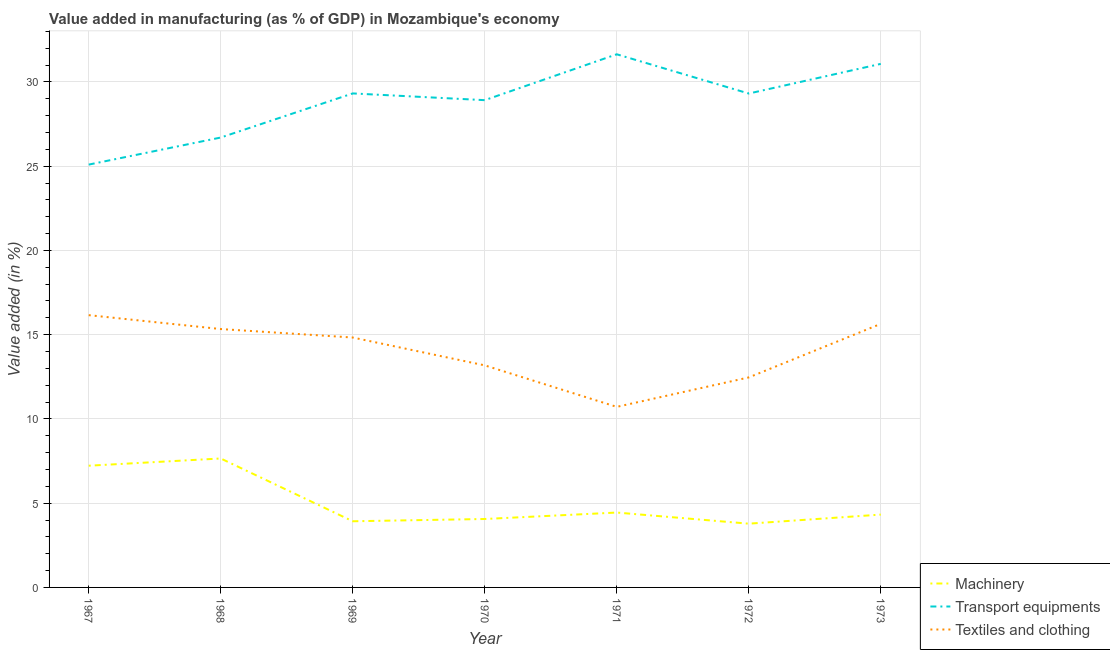How many different coloured lines are there?
Offer a terse response. 3. Does the line corresponding to value added in manufacturing machinery intersect with the line corresponding to value added in manufacturing transport equipments?
Keep it short and to the point. No. What is the value added in manufacturing textile and clothing in 1973?
Give a very brief answer. 15.64. Across all years, what is the maximum value added in manufacturing textile and clothing?
Your answer should be very brief. 16.16. Across all years, what is the minimum value added in manufacturing textile and clothing?
Ensure brevity in your answer.  10.72. In which year was the value added in manufacturing machinery maximum?
Provide a succinct answer. 1968. What is the total value added in manufacturing machinery in the graph?
Provide a short and direct response. 35.42. What is the difference between the value added in manufacturing machinery in 1968 and that in 1971?
Keep it short and to the point. 3.21. What is the difference between the value added in manufacturing transport equipments in 1967 and the value added in manufacturing machinery in 1970?
Ensure brevity in your answer.  21.03. What is the average value added in manufacturing machinery per year?
Your response must be concise. 5.06. In the year 1971, what is the difference between the value added in manufacturing machinery and value added in manufacturing textile and clothing?
Provide a short and direct response. -6.27. In how many years, is the value added in manufacturing transport equipments greater than 30 %?
Ensure brevity in your answer.  2. What is the ratio of the value added in manufacturing textile and clothing in 1967 to that in 1968?
Provide a short and direct response. 1.05. Is the value added in manufacturing textile and clothing in 1967 less than that in 1968?
Offer a very short reply. No. Is the difference between the value added in manufacturing machinery in 1967 and 1971 greater than the difference between the value added in manufacturing textile and clothing in 1967 and 1971?
Provide a succinct answer. No. What is the difference between the highest and the second highest value added in manufacturing machinery?
Your answer should be very brief. 0.43. What is the difference between the highest and the lowest value added in manufacturing transport equipments?
Offer a terse response. 6.55. In how many years, is the value added in manufacturing transport equipments greater than the average value added in manufacturing transport equipments taken over all years?
Your answer should be compact. 5. Is the sum of the value added in manufacturing textile and clothing in 1971 and 1972 greater than the maximum value added in manufacturing transport equipments across all years?
Offer a very short reply. No. Is the value added in manufacturing transport equipments strictly less than the value added in manufacturing machinery over the years?
Offer a very short reply. No. How many lines are there?
Make the answer very short. 3. How many years are there in the graph?
Make the answer very short. 7. What is the difference between two consecutive major ticks on the Y-axis?
Provide a short and direct response. 5. Does the graph contain grids?
Ensure brevity in your answer.  Yes. Where does the legend appear in the graph?
Your answer should be compact. Bottom right. How are the legend labels stacked?
Make the answer very short. Vertical. What is the title of the graph?
Give a very brief answer. Value added in manufacturing (as % of GDP) in Mozambique's economy. What is the label or title of the Y-axis?
Your answer should be very brief. Value added (in %). What is the Value added (in %) in Machinery in 1967?
Keep it short and to the point. 7.22. What is the Value added (in %) in Transport equipments in 1967?
Provide a succinct answer. 25.09. What is the Value added (in %) in Textiles and clothing in 1967?
Keep it short and to the point. 16.16. What is the Value added (in %) in Machinery in 1968?
Your answer should be very brief. 7.65. What is the Value added (in %) in Transport equipments in 1968?
Offer a terse response. 26.7. What is the Value added (in %) in Textiles and clothing in 1968?
Give a very brief answer. 15.33. What is the Value added (in %) in Machinery in 1969?
Offer a very short reply. 3.93. What is the Value added (in %) in Transport equipments in 1969?
Provide a short and direct response. 29.32. What is the Value added (in %) in Textiles and clothing in 1969?
Make the answer very short. 14.83. What is the Value added (in %) of Machinery in 1970?
Provide a succinct answer. 4.06. What is the Value added (in %) of Transport equipments in 1970?
Offer a terse response. 28.92. What is the Value added (in %) of Textiles and clothing in 1970?
Offer a terse response. 13.18. What is the Value added (in %) in Machinery in 1971?
Provide a short and direct response. 4.44. What is the Value added (in %) in Transport equipments in 1971?
Offer a terse response. 31.64. What is the Value added (in %) in Textiles and clothing in 1971?
Ensure brevity in your answer.  10.72. What is the Value added (in %) of Machinery in 1972?
Provide a succinct answer. 3.78. What is the Value added (in %) in Transport equipments in 1972?
Your answer should be very brief. 29.31. What is the Value added (in %) in Textiles and clothing in 1972?
Make the answer very short. 12.46. What is the Value added (in %) in Machinery in 1973?
Provide a short and direct response. 4.32. What is the Value added (in %) of Transport equipments in 1973?
Keep it short and to the point. 31.07. What is the Value added (in %) in Textiles and clothing in 1973?
Offer a very short reply. 15.64. Across all years, what is the maximum Value added (in %) of Machinery?
Provide a succinct answer. 7.65. Across all years, what is the maximum Value added (in %) of Transport equipments?
Your answer should be very brief. 31.64. Across all years, what is the maximum Value added (in %) in Textiles and clothing?
Offer a very short reply. 16.16. Across all years, what is the minimum Value added (in %) of Machinery?
Offer a terse response. 3.78. Across all years, what is the minimum Value added (in %) of Transport equipments?
Make the answer very short. 25.09. Across all years, what is the minimum Value added (in %) in Textiles and clothing?
Provide a short and direct response. 10.72. What is the total Value added (in %) of Machinery in the graph?
Provide a short and direct response. 35.42. What is the total Value added (in %) of Transport equipments in the graph?
Make the answer very short. 202.06. What is the total Value added (in %) in Textiles and clothing in the graph?
Your response must be concise. 98.33. What is the difference between the Value added (in %) in Machinery in 1967 and that in 1968?
Your answer should be very brief. -0.43. What is the difference between the Value added (in %) of Transport equipments in 1967 and that in 1968?
Your answer should be compact. -1.61. What is the difference between the Value added (in %) in Textiles and clothing in 1967 and that in 1968?
Offer a very short reply. 0.82. What is the difference between the Value added (in %) of Machinery in 1967 and that in 1969?
Your answer should be very brief. 3.3. What is the difference between the Value added (in %) in Transport equipments in 1967 and that in 1969?
Offer a very short reply. -4.22. What is the difference between the Value added (in %) in Textiles and clothing in 1967 and that in 1969?
Your answer should be very brief. 1.33. What is the difference between the Value added (in %) in Machinery in 1967 and that in 1970?
Offer a very short reply. 3.16. What is the difference between the Value added (in %) of Transport equipments in 1967 and that in 1970?
Ensure brevity in your answer.  -3.82. What is the difference between the Value added (in %) in Textiles and clothing in 1967 and that in 1970?
Offer a terse response. 2.98. What is the difference between the Value added (in %) of Machinery in 1967 and that in 1971?
Make the answer very short. 2.78. What is the difference between the Value added (in %) of Transport equipments in 1967 and that in 1971?
Offer a very short reply. -6.55. What is the difference between the Value added (in %) of Textiles and clothing in 1967 and that in 1971?
Your answer should be compact. 5.44. What is the difference between the Value added (in %) of Machinery in 1967 and that in 1972?
Give a very brief answer. 3.44. What is the difference between the Value added (in %) in Transport equipments in 1967 and that in 1972?
Provide a succinct answer. -4.22. What is the difference between the Value added (in %) of Textiles and clothing in 1967 and that in 1972?
Your answer should be very brief. 3.69. What is the difference between the Value added (in %) of Machinery in 1967 and that in 1973?
Provide a short and direct response. 2.9. What is the difference between the Value added (in %) in Transport equipments in 1967 and that in 1973?
Provide a short and direct response. -5.98. What is the difference between the Value added (in %) of Textiles and clothing in 1967 and that in 1973?
Provide a short and direct response. 0.52. What is the difference between the Value added (in %) of Machinery in 1968 and that in 1969?
Provide a short and direct response. 3.73. What is the difference between the Value added (in %) of Transport equipments in 1968 and that in 1969?
Your response must be concise. -2.62. What is the difference between the Value added (in %) in Textiles and clothing in 1968 and that in 1969?
Provide a short and direct response. 0.5. What is the difference between the Value added (in %) in Machinery in 1968 and that in 1970?
Make the answer very short. 3.59. What is the difference between the Value added (in %) in Transport equipments in 1968 and that in 1970?
Give a very brief answer. -2.22. What is the difference between the Value added (in %) in Textiles and clothing in 1968 and that in 1970?
Your response must be concise. 2.16. What is the difference between the Value added (in %) in Machinery in 1968 and that in 1971?
Provide a short and direct response. 3.21. What is the difference between the Value added (in %) of Transport equipments in 1968 and that in 1971?
Your answer should be compact. -4.94. What is the difference between the Value added (in %) of Textiles and clothing in 1968 and that in 1971?
Your response must be concise. 4.62. What is the difference between the Value added (in %) of Machinery in 1968 and that in 1972?
Make the answer very short. 3.87. What is the difference between the Value added (in %) in Transport equipments in 1968 and that in 1972?
Provide a succinct answer. -2.61. What is the difference between the Value added (in %) in Textiles and clothing in 1968 and that in 1972?
Your response must be concise. 2.87. What is the difference between the Value added (in %) of Machinery in 1968 and that in 1973?
Your answer should be very brief. 3.33. What is the difference between the Value added (in %) in Transport equipments in 1968 and that in 1973?
Offer a very short reply. -4.37. What is the difference between the Value added (in %) of Textiles and clothing in 1968 and that in 1973?
Keep it short and to the point. -0.31. What is the difference between the Value added (in %) in Machinery in 1969 and that in 1970?
Provide a short and direct response. -0.14. What is the difference between the Value added (in %) in Transport equipments in 1969 and that in 1970?
Ensure brevity in your answer.  0.4. What is the difference between the Value added (in %) in Textiles and clothing in 1969 and that in 1970?
Offer a very short reply. 1.65. What is the difference between the Value added (in %) in Machinery in 1969 and that in 1971?
Your answer should be very brief. -0.52. What is the difference between the Value added (in %) of Transport equipments in 1969 and that in 1971?
Give a very brief answer. -2.32. What is the difference between the Value added (in %) of Textiles and clothing in 1969 and that in 1971?
Your response must be concise. 4.12. What is the difference between the Value added (in %) in Machinery in 1969 and that in 1972?
Your response must be concise. 0.14. What is the difference between the Value added (in %) of Transport equipments in 1969 and that in 1972?
Your response must be concise. 0.01. What is the difference between the Value added (in %) of Textiles and clothing in 1969 and that in 1972?
Ensure brevity in your answer.  2.37. What is the difference between the Value added (in %) in Machinery in 1969 and that in 1973?
Make the answer very short. -0.4. What is the difference between the Value added (in %) of Transport equipments in 1969 and that in 1973?
Your answer should be very brief. -1.75. What is the difference between the Value added (in %) of Textiles and clothing in 1969 and that in 1973?
Provide a succinct answer. -0.81. What is the difference between the Value added (in %) in Machinery in 1970 and that in 1971?
Make the answer very short. -0.38. What is the difference between the Value added (in %) of Transport equipments in 1970 and that in 1971?
Provide a succinct answer. -2.72. What is the difference between the Value added (in %) in Textiles and clothing in 1970 and that in 1971?
Provide a succinct answer. 2.46. What is the difference between the Value added (in %) in Machinery in 1970 and that in 1972?
Provide a succinct answer. 0.28. What is the difference between the Value added (in %) of Transport equipments in 1970 and that in 1972?
Give a very brief answer. -0.39. What is the difference between the Value added (in %) of Textiles and clothing in 1970 and that in 1972?
Make the answer very short. 0.71. What is the difference between the Value added (in %) of Machinery in 1970 and that in 1973?
Keep it short and to the point. -0.26. What is the difference between the Value added (in %) of Transport equipments in 1970 and that in 1973?
Your answer should be very brief. -2.15. What is the difference between the Value added (in %) in Textiles and clothing in 1970 and that in 1973?
Provide a short and direct response. -2.46. What is the difference between the Value added (in %) of Machinery in 1971 and that in 1972?
Your answer should be compact. 0.66. What is the difference between the Value added (in %) in Transport equipments in 1971 and that in 1972?
Offer a very short reply. 2.33. What is the difference between the Value added (in %) of Textiles and clothing in 1971 and that in 1972?
Your answer should be compact. -1.75. What is the difference between the Value added (in %) in Machinery in 1971 and that in 1973?
Offer a very short reply. 0.12. What is the difference between the Value added (in %) in Transport equipments in 1971 and that in 1973?
Ensure brevity in your answer.  0.57. What is the difference between the Value added (in %) of Textiles and clothing in 1971 and that in 1973?
Provide a short and direct response. -4.93. What is the difference between the Value added (in %) in Machinery in 1972 and that in 1973?
Give a very brief answer. -0.54. What is the difference between the Value added (in %) in Transport equipments in 1972 and that in 1973?
Your response must be concise. -1.76. What is the difference between the Value added (in %) of Textiles and clothing in 1972 and that in 1973?
Make the answer very short. -3.18. What is the difference between the Value added (in %) of Machinery in 1967 and the Value added (in %) of Transport equipments in 1968?
Ensure brevity in your answer.  -19.48. What is the difference between the Value added (in %) in Machinery in 1967 and the Value added (in %) in Textiles and clothing in 1968?
Ensure brevity in your answer.  -8.11. What is the difference between the Value added (in %) of Transport equipments in 1967 and the Value added (in %) of Textiles and clothing in 1968?
Your response must be concise. 9.76. What is the difference between the Value added (in %) in Machinery in 1967 and the Value added (in %) in Transport equipments in 1969?
Ensure brevity in your answer.  -22.09. What is the difference between the Value added (in %) of Machinery in 1967 and the Value added (in %) of Textiles and clothing in 1969?
Your answer should be compact. -7.61. What is the difference between the Value added (in %) of Transport equipments in 1967 and the Value added (in %) of Textiles and clothing in 1969?
Your answer should be very brief. 10.26. What is the difference between the Value added (in %) of Machinery in 1967 and the Value added (in %) of Transport equipments in 1970?
Your answer should be very brief. -21.69. What is the difference between the Value added (in %) of Machinery in 1967 and the Value added (in %) of Textiles and clothing in 1970?
Make the answer very short. -5.96. What is the difference between the Value added (in %) of Transport equipments in 1967 and the Value added (in %) of Textiles and clothing in 1970?
Provide a succinct answer. 11.92. What is the difference between the Value added (in %) of Machinery in 1967 and the Value added (in %) of Transport equipments in 1971?
Your answer should be very brief. -24.42. What is the difference between the Value added (in %) in Machinery in 1967 and the Value added (in %) in Textiles and clothing in 1971?
Give a very brief answer. -3.49. What is the difference between the Value added (in %) in Transport equipments in 1967 and the Value added (in %) in Textiles and clothing in 1971?
Provide a short and direct response. 14.38. What is the difference between the Value added (in %) of Machinery in 1967 and the Value added (in %) of Transport equipments in 1972?
Give a very brief answer. -22.09. What is the difference between the Value added (in %) of Machinery in 1967 and the Value added (in %) of Textiles and clothing in 1972?
Offer a terse response. -5.24. What is the difference between the Value added (in %) in Transport equipments in 1967 and the Value added (in %) in Textiles and clothing in 1972?
Offer a very short reply. 12.63. What is the difference between the Value added (in %) of Machinery in 1967 and the Value added (in %) of Transport equipments in 1973?
Your answer should be compact. -23.85. What is the difference between the Value added (in %) in Machinery in 1967 and the Value added (in %) in Textiles and clothing in 1973?
Your response must be concise. -8.42. What is the difference between the Value added (in %) of Transport equipments in 1967 and the Value added (in %) of Textiles and clothing in 1973?
Ensure brevity in your answer.  9.45. What is the difference between the Value added (in %) in Machinery in 1968 and the Value added (in %) in Transport equipments in 1969?
Provide a short and direct response. -21.67. What is the difference between the Value added (in %) in Machinery in 1968 and the Value added (in %) in Textiles and clothing in 1969?
Your answer should be compact. -7.18. What is the difference between the Value added (in %) in Transport equipments in 1968 and the Value added (in %) in Textiles and clothing in 1969?
Your answer should be very brief. 11.87. What is the difference between the Value added (in %) of Machinery in 1968 and the Value added (in %) of Transport equipments in 1970?
Ensure brevity in your answer.  -21.27. What is the difference between the Value added (in %) in Machinery in 1968 and the Value added (in %) in Textiles and clothing in 1970?
Ensure brevity in your answer.  -5.53. What is the difference between the Value added (in %) in Transport equipments in 1968 and the Value added (in %) in Textiles and clothing in 1970?
Your answer should be very brief. 13.52. What is the difference between the Value added (in %) of Machinery in 1968 and the Value added (in %) of Transport equipments in 1971?
Your response must be concise. -23.99. What is the difference between the Value added (in %) in Machinery in 1968 and the Value added (in %) in Textiles and clothing in 1971?
Offer a very short reply. -3.06. What is the difference between the Value added (in %) in Transport equipments in 1968 and the Value added (in %) in Textiles and clothing in 1971?
Offer a terse response. 15.98. What is the difference between the Value added (in %) in Machinery in 1968 and the Value added (in %) in Transport equipments in 1972?
Make the answer very short. -21.66. What is the difference between the Value added (in %) in Machinery in 1968 and the Value added (in %) in Textiles and clothing in 1972?
Your answer should be very brief. -4.81. What is the difference between the Value added (in %) in Transport equipments in 1968 and the Value added (in %) in Textiles and clothing in 1972?
Your answer should be compact. 14.24. What is the difference between the Value added (in %) of Machinery in 1968 and the Value added (in %) of Transport equipments in 1973?
Keep it short and to the point. -23.42. What is the difference between the Value added (in %) of Machinery in 1968 and the Value added (in %) of Textiles and clothing in 1973?
Offer a very short reply. -7.99. What is the difference between the Value added (in %) in Transport equipments in 1968 and the Value added (in %) in Textiles and clothing in 1973?
Keep it short and to the point. 11.06. What is the difference between the Value added (in %) of Machinery in 1969 and the Value added (in %) of Transport equipments in 1970?
Make the answer very short. -24.99. What is the difference between the Value added (in %) in Machinery in 1969 and the Value added (in %) in Textiles and clothing in 1970?
Provide a short and direct response. -9.25. What is the difference between the Value added (in %) of Transport equipments in 1969 and the Value added (in %) of Textiles and clothing in 1970?
Keep it short and to the point. 16.14. What is the difference between the Value added (in %) in Machinery in 1969 and the Value added (in %) in Transport equipments in 1971?
Give a very brief answer. -27.71. What is the difference between the Value added (in %) in Machinery in 1969 and the Value added (in %) in Textiles and clothing in 1971?
Provide a short and direct response. -6.79. What is the difference between the Value added (in %) of Transport equipments in 1969 and the Value added (in %) of Textiles and clothing in 1971?
Your answer should be compact. 18.6. What is the difference between the Value added (in %) in Machinery in 1969 and the Value added (in %) in Transport equipments in 1972?
Your response must be concise. -25.39. What is the difference between the Value added (in %) of Machinery in 1969 and the Value added (in %) of Textiles and clothing in 1972?
Provide a short and direct response. -8.54. What is the difference between the Value added (in %) in Transport equipments in 1969 and the Value added (in %) in Textiles and clothing in 1972?
Provide a short and direct response. 16.85. What is the difference between the Value added (in %) in Machinery in 1969 and the Value added (in %) in Transport equipments in 1973?
Your answer should be compact. -27.15. What is the difference between the Value added (in %) of Machinery in 1969 and the Value added (in %) of Textiles and clothing in 1973?
Offer a terse response. -11.72. What is the difference between the Value added (in %) of Transport equipments in 1969 and the Value added (in %) of Textiles and clothing in 1973?
Provide a short and direct response. 13.68. What is the difference between the Value added (in %) in Machinery in 1970 and the Value added (in %) in Transport equipments in 1971?
Ensure brevity in your answer.  -27.58. What is the difference between the Value added (in %) of Machinery in 1970 and the Value added (in %) of Textiles and clothing in 1971?
Your response must be concise. -6.65. What is the difference between the Value added (in %) in Transport equipments in 1970 and the Value added (in %) in Textiles and clothing in 1971?
Keep it short and to the point. 18.2. What is the difference between the Value added (in %) in Machinery in 1970 and the Value added (in %) in Transport equipments in 1972?
Provide a short and direct response. -25.25. What is the difference between the Value added (in %) of Machinery in 1970 and the Value added (in %) of Textiles and clothing in 1972?
Give a very brief answer. -8.4. What is the difference between the Value added (in %) of Transport equipments in 1970 and the Value added (in %) of Textiles and clothing in 1972?
Make the answer very short. 16.45. What is the difference between the Value added (in %) in Machinery in 1970 and the Value added (in %) in Transport equipments in 1973?
Your answer should be very brief. -27.01. What is the difference between the Value added (in %) of Machinery in 1970 and the Value added (in %) of Textiles and clothing in 1973?
Provide a short and direct response. -11.58. What is the difference between the Value added (in %) in Transport equipments in 1970 and the Value added (in %) in Textiles and clothing in 1973?
Your answer should be very brief. 13.28. What is the difference between the Value added (in %) in Machinery in 1971 and the Value added (in %) in Transport equipments in 1972?
Keep it short and to the point. -24.87. What is the difference between the Value added (in %) of Machinery in 1971 and the Value added (in %) of Textiles and clothing in 1972?
Provide a short and direct response. -8.02. What is the difference between the Value added (in %) of Transport equipments in 1971 and the Value added (in %) of Textiles and clothing in 1972?
Your answer should be very brief. 19.18. What is the difference between the Value added (in %) in Machinery in 1971 and the Value added (in %) in Transport equipments in 1973?
Offer a very short reply. -26.63. What is the difference between the Value added (in %) of Machinery in 1971 and the Value added (in %) of Textiles and clothing in 1973?
Give a very brief answer. -11.2. What is the difference between the Value added (in %) of Transport equipments in 1971 and the Value added (in %) of Textiles and clothing in 1973?
Your answer should be compact. 16. What is the difference between the Value added (in %) of Machinery in 1972 and the Value added (in %) of Transport equipments in 1973?
Offer a very short reply. -27.29. What is the difference between the Value added (in %) of Machinery in 1972 and the Value added (in %) of Textiles and clothing in 1973?
Your answer should be very brief. -11.86. What is the difference between the Value added (in %) of Transport equipments in 1972 and the Value added (in %) of Textiles and clothing in 1973?
Your response must be concise. 13.67. What is the average Value added (in %) in Machinery per year?
Provide a succinct answer. 5.06. What is the average Value added (in %) of Transport equipments per year?
Your answer should be very brief. 28.87. What is the average Value added (in %) of Textiles and clothing per year?
Your answer should be very brief. 14.05. In the year 1967, what is the difference between the Value added (in %) of Machinery and Value added (in %) of Transport equipments?
Provide a short and direct response. -17.87. In the year 1967, what is the difference between the Value added (in %) of Machinery and Value added (in %) of Textiles and clothing?
Your response must be concise. -8.94. In the year 1967, what is the difference between the Value added (in %) in Transport equipments and Value added (in %) in Textiles and clothing?
Ensure brevity in your answer.  8.94. In the year 1968, what is the difference between the Value added (in %) in Machinery and Value added (in %) in Transport equipments?
Make the answer very short. -19.05. In the year 1968, what is the difference between the Value added (in %) in Machinery and Value added (in %) in Textiles and clothing?
Provide a succinct answer. -7.68. In the year 1968, what is the difference between the Value added (in %) of Transport equipments and Value added (in %) of Textiles and clothing?
Make the answer very short. 11.37. In the year 1969, what is the difference between the Value added (in %) of Machinery and Value added (in %) of Transport equipments?
Ensure brevity in your answer.  -25.39. In the year 1969, what is the difference between the Value added (in %) in Machinery and Value added (in %) in Textiles and clothing?
Provide a short and direct response. -10.9. In the year 1969, what is the difference between the Value added (in %) in Transport equipments and Value added (in %) in Textiles and clothing?
Your answer should be very brief. 14.49. In the year 1970, what is the difference between the Value added (in %) of Machinery and Value added (in %) of Transport equipments?
Give a very brief answer. -24.86. In the year 1970, what is the difference between the Value added (in %) in Machinery and Value added (in %) in Textiles and clothing?
Your response must be concise. -9.12. In the year 1970, what is the difference between the Value added (in %) of Transport equipments and Value added (in %) of Textiles and clothing?
Your answer should be compact. 15.74. In the year 1971, what is the difference between the Value added (in %) in Machinery and Value added (in %) in Transport equipments?
Keep it short and to the point. -27.2. In the year 1971, what is the difference between the Value added (in %) of Machinery and Value added (in %) of Textiles and clothing?
Your response must be concise. -6.27. In the year 1971, what is the difference between the Value added (in %) in Transport equipments and Value added (in %) in Textiles and clothing?
Your answer should be very brief. 20.92. In the year 1972, what is the difference between the Value added (in %) of Machinery and Value added (in %) of Transport equipments?
Give a very brief answer. -25.53. In the year 1972, what is the difference between the Value added (in %) in Machinery and Value added (in %) in Textiles and clothing?
Offer a terse response. -8.68. In the year 1972, what is the difference between the Value added (in %) in Transport equipments and Value added (in %) in Textiles and clothing?
Offer a very short reply. 16.85. In the year 1973, what is the difference between the Value added (in %) in Machinery and Value added (in %) in Transport equipments?
Your response must be concise. -26.75. In the year 1973, what is the difference between the Value added (in %) of Machinery and Value added (in %) of Textiles and clothing?
Ensure brevity in your answer.  -11.32. In the year 1973, what is the difference between the Value added (in %) in Transport equipments and Value added (in %) in Textiles and clothing?
Keep it short and to the point. 15.43. What is the ratio of the Value added (in %) of Machinery in 1967 to that in 1968?
Give a very brief answer. 0.94. What is the ratio of the Value added (in %) in Transport equipments in 1967 to that in 1968?
Offer a terse response. 0.94. What is the ratio of the Value added (in %) in Textiles and clothing in 1967 to that in 1968?
Provide a succinct answer. 1.05. What is the ratio of the Value added (in %) in Machinery in 1967 to that in 1969?
Your response must be concise. 1.84. What is the ratio of the Value added (in %) in Transport equipments in 1967 to that in 1969?
Ensure brevity in your answer.  0.86. What is the ratio of the Value added (in %) of Textiles and clothing in 1967 to that in 1969?
Provide a short and direct response. 1.09. What is the ratio of the Value added (in %) of Machinery in 1967 to that in 1970?
Your answer should be compact. 1.78. What is the ratio of the Value added (in %) of Transport equipments in 1967 to that in 1970?
Provide a short and direct response. 0.87. What is the ratio of the Value added (in %) in Textiles and clothing in 1967 to that in 1970?
Your answer should be very brief. 1.23. What is the ratio of the Value added (in %) of Machinery in 1967 to that in 1971?
Your response must be concise. 1.63. What is the ratio of the Value added (in %) of Transport equipments in 1967 to that in 1971?
Your answer should be very brief. 0.79. What is the ratio of the Value added (in %) of Textiles and clothing in 1967 to that in 1971?
Ensure brevity in your answer.  1.51. What is the ratio of the Value added (in %) in Machinery in 1967 to that in 1972?
Make the answer very short. 1.91. What is the ratio of the Value added (in %) of Transport equipments in 1967 to that in 1972?
Offer a terse response. 0.86. What is the ratio of the Value added (in %) in Textiles and clothing in 1967 to that in 1972?
Provide a succinct answer. 1.3. What is the ratio of the Value added (in %) of Machinery in 1967 to that in 1973?
Give a very brief answer. 1.67. What is the ratio of the Value added (in %) of Transport equipments in 1967 to that in 1973?
Provide a short and direct response. 0.81. What is the ratio of the Value added (in %) of Textiles and clothing in 1967 to that in 1973?
Provide a succinct answer. 1.03. What is the ratio of the Value added (in %) of Machinery in 1968 to that in 1969?
Give a very brief answer. 1.95. What is the ratio of the Value added (in %) of Transport equipments in 1968 to that in 1969?
Your answer should be compact. 0.91. What is the ratio of the Value added (in %) of Textiles and clothing in 1968 to that in 1969?
Ensure brevity in your answer.  1.03. What is the ratio of the Value added (in %) in Machinery in 1968 to that in 1970?
Your answer should be very brief. 1.88. What is the ratio of the Value added (in %) in Transport equipments in 1968 to that in 1970?
Keep it short and to the point. 0.92. What is the ratio of the Value added (in %) of Textiles and clothing in 1968 to that in 1970?
Provide a short and direct response. 1.16. What is the ratio of the Value added (in %) of Machinery in 1968 to that in 1971?
Your response must be concise. 1.72. What is the ratio of the Value added (in %) in Transport equipments in 1968 to that in 1971?
Give a very brief answer. 0.84. What is the ratio of the Value added (in %) of Textiles and clothing in 1968 to that in 1971?
Make the answer very short. 1.43. What is the ratio of the Value added (in %) of Machinery in 1968 to that in 1972?
Your answer should be compact. 2.02. What is the ratio of the Value added (in %) of Transport equipments in 1968 to that in 1972?
Offer a terse response. 0.91. What is the ratio of the Value added (in %) in Textiles and clothing in 1968 to that in 1972?
Provide a short and direct response. 1.23. What is the ratio of the Value added (in %) of Machinery in 1968 to that in 1973?
Make the answer very short. 1.77. What is the ratio of the Value added (in %) in Transport equipments in 1968 to that in 1973?
Ensure brevity in your answer.  0.86. What is the ratio of the Value added (in %) in Textiles and clothing in 1968 to that in 1973?
Give a very brief answer. 0.98. What is the ratio of the Value added (in %) of Machinery in 1969 to that in 1970?
Your response must be concise. 0.97. What is the ratio of the Value added (in %) of Transport equipments in 1969 to that in 1970?
Your answer should be very brief. 1.01. What is the ratio of the Value added (in %) in Textiles and clothing in 1969 to that in 1970?
Offer a terse response. 1.13. What is the ratio of the Value added (in %) of Machinery in 1969 to that in 1971?
Your response must be concise. 0.88. What is the ratio of the Value added (in %) in Transport equipments in 1969 to that in 1971?
Offer a terse response. 0.93. What is the ratio of the Value added (in %) of Textiles and clothing in 1969 to that in 1971?
Provide a succinct answer. 1.38. What is the ratio of the Value added (in %) of Machinery in 1969 to that in 1972?
Provide a short and direct response. 1.04. What is the ratio of the Value added (in %) in Transport equipments in 1969 to that in 1972?
Keep it short and to the point. 1. What is the ratio of the Value added (in %) of Textiles and clothing in 1969 to that in 1972?
Provide a succinct answer. 1.19. What is the ratio of the Value added (in %) in Machinery in 1969 to that in 1973?
Give a very brief answer. 0.91. What is the ratio of the Value added (in %) of Transport equipments in 1969 to that in 1973?
Provide a succinct answer. 0.94. What is the ratio of the Value added (in %) in Textiles and clothing in 1969 to that in 1973?
Ensure brevity in your answer.  0.95. What is the ratio of the Value added (in %) in Machinery in 1970 to that in 1971?
Keep it short and to the point. 0.91. What is the ratio of the Value added (in %) of Transport equipments in 1970 to that in 1971?
Provide a short and direct response. 0.91. What is the ratio of the Value added (in %) of Textiles and clothing in 1970 to that in 1971?
Provide a succinct answer. 1.23. What is the ratio of the Value added (in %) of Machinery in 1970 to that in 1972?
Offer a terse response. 1.07. What is the ratio of the Value added (in %) in Transport equipments in 1970 to that in 1972?
Give a very brief answer. 0.99. What is the ratio of the Value added (in %) in Textiles and clothing in 1970 to that in 1972?
Keep it short and to the point. 1.06. What is the ratio of the Value added (in %) in Machinery in 1970 to that in 1973?
Offer a very short reply. 0.94. What is the ratio of the Value added (in %) in Transport equipments in 1970 to that in 1973?
Make the answer very short. 0.93. What is the ratio of the Value added (in %) in Textiles and clothing in 1970 to that in 1973?
Your answer should be compact. 0.84. What is the ratio of the Value added (in %) of Machinery in 1971 to that in 1972?
Provide a short and direct response. 1.17. What is the ratio of the Value added (in %) in Transport equipments in 1971 to that in 1972?
Ensure brevity in your answer.  1.08. What is the ratio of the Value added (in %) in Textiles and clothing in 1971 to that in 1972?
Give a very brief answer. 0.86. What is the ratio of the Value added (in %) of Machinery in 1971 to that in 1973?
Keep it short and to the point. 1.03. What is the ratio of the Value added (in %) in Transport equipments in 1971 to that in 1973?
Make the answer very short. 1.02. What is the ratio of the Value added (in %) of Textiles and clothing in 1971 to that in 1973?
Keep it short and to the point. 0.69. What is the ratio of the Value added (in %) in Machinery in 1972 to that in 1973?
Provide a short and direct response. 0.88. What is the ratio of the Value added (in %) of Transport equipments in 1972 to that in 1973?
Make the answer very short. 0.94. What is the ratio of the Value added (in %) in Textiles and clothing in 1972 to that in 1973?
Your answer should be very brief. 0.8. What is the difference between the highest and the second highest Value added (in %) in Machinery?
Provide a short and direct response. 0.43. What is the difference between the highest and the second highest Value added (in %) in Transport equipments?
Provide a short and direct response. 0.57. What is the difference between the highest and the second highest Value added (in %) of Textiles and clothing?
Provide a succinct answer. 0.52. What is the difference between the highest and the lowest Value added (in %) of Machinery?
Offer a very short reply. 3.87. What is the difference between the highest and the lowest Value added (in %) in Transport equipments?
Provide a succinct answer. 6.55. What is the difference between the highest and the lowest Value added (in %) of Textiles and clothing?
Provide a short and direct response. 5.44. 